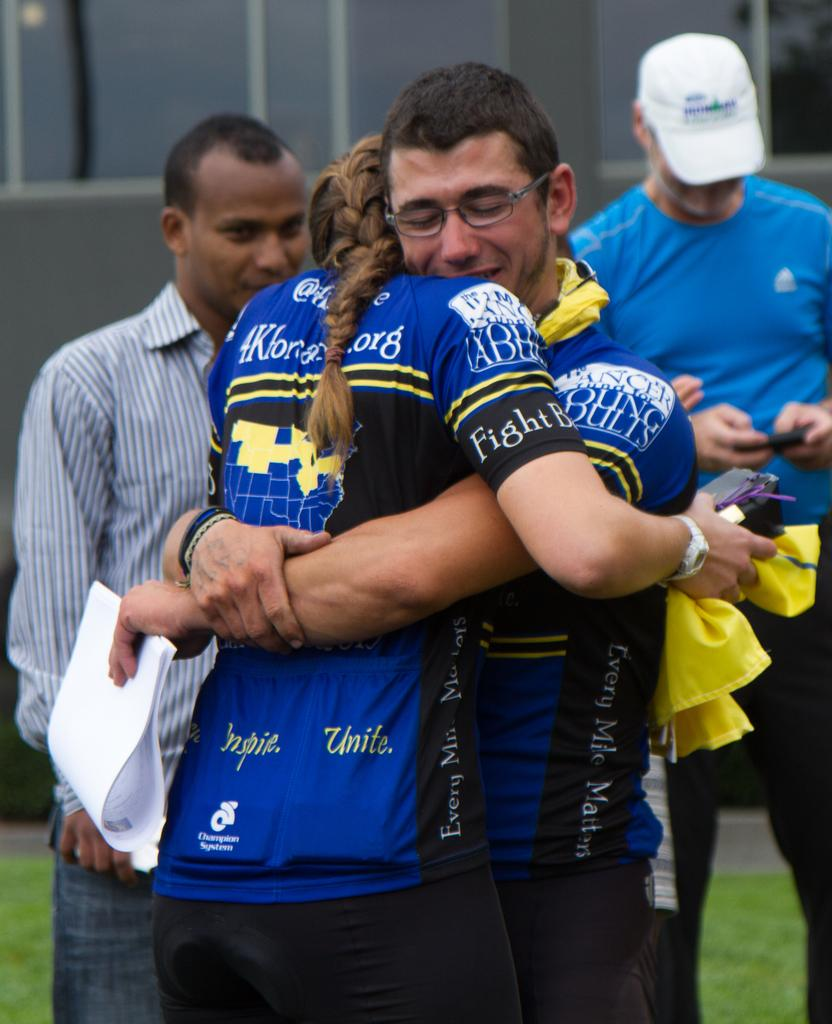Who are the people in the image? There is a man and a woman in the image. What are the man and woman doing in the image? The man and woman are hugging each other. Are there any other people visible in the image? Yes, there are two men in the background of the image. What type of ticket is the woman holding in the image? There is no ticket present in the image; the woman is hugging the man. 